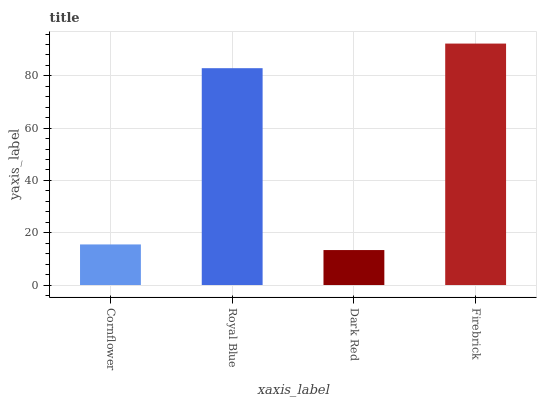Is Dark Red the minimum?
Answer yes or no. Yes. Is Firebrick the maximum?
Answer yes or no. Yes. Is Royal Blue the minimum?
Answer yes or no. No. Is Royal Blue the maximum?
Answer yes or no. No. Is Royal Blue greater than Cornflower?
Answer yes or no. Yes. Is Cornflower less than Royal Blue?
Answer yes or no. Yes. Is Cornflower greater than Royal Blue?
Answer yes or no. No. Is Royal Blue less than Cornflower?
Answer yes or no. No. Is Royal Blue the high median?
Answer yes or no. Yes. Is Cornflower the low median?
Answer yes or no. Yes. Is Firebrick the high median?
Answer yes or no. No. Is Royal Blue the low median?
Answer yes or no. No. 